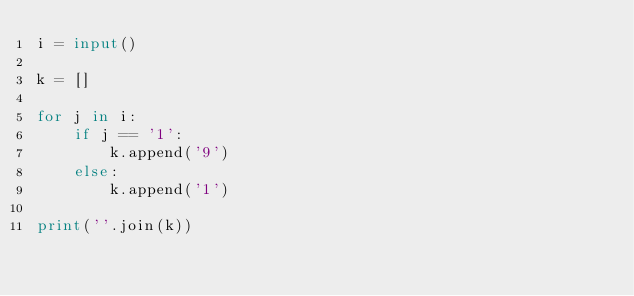<code> <loc_0><loc_0><loc_500><loc_500><_Python_>i = input()

k = []

for j in i:
    if j == '1':
        k.append('9')
    else:
        k.append('1')

print(''.join(k))
</code> 